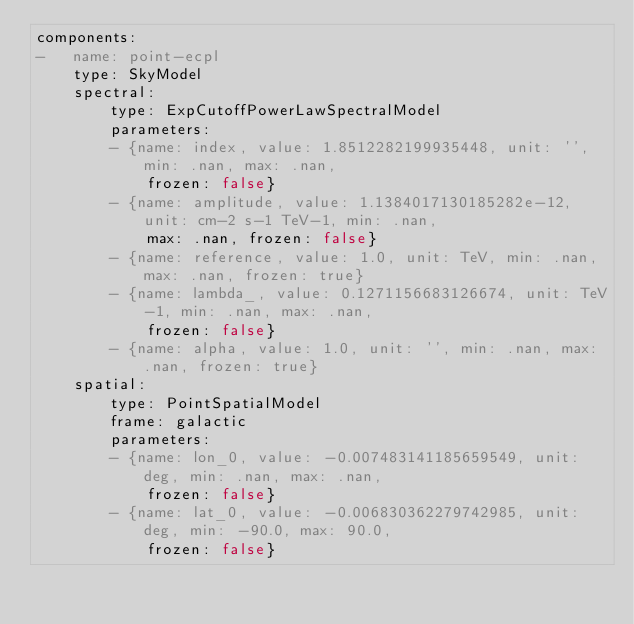Convert code to text. <code><loc_0><loc_0><loc_500><loc_500><_YAML_>components:
-   name: point-ecpl
    type: SkyModel
    spectral:
        type: ExpCutoffPowerLawSpectralModel
        parameters:
        - {name: index, value: 1.8512282199935448, unit: '', min: .nan, max: .nan,
            frozen: false}
        - {name: amplitude, value: 1.1384017130185282e-12, unit: cm-2 s-1 TeV-1, min: .nan,
            max: .nan, frozen: false}
        - {name: reference, value: 1.0, unit: TeV, min: .nan, max: .nan, frozen: true}
        - {name: lambda_, value: 0.1271156683126674, unit: TeV-1, min: .nan, max: .nan,
            frozen: false}
        - {name: alpha, value: 1.0, unit: '', min: .nan, max: .nan, frozen: true}
    spatial:
        type: PointSpatialModel
        frame: galactic
        parameters:
        - {name: lon_0, value: -0.007483141185659549, unit: deg, min: .nan, max: .nan,
            frozen: false}
        - {name: lat_0, value: -0.006830362279742985, unit: deg, min: -90.0, max: 90.0,
            frozen: false}
</code> 